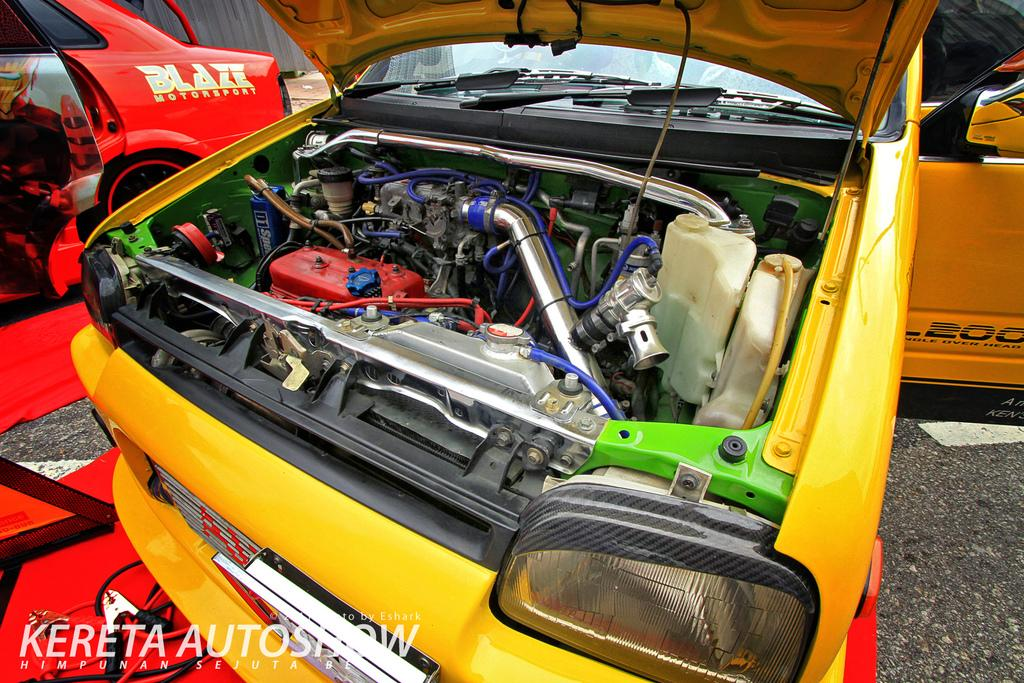What is the main subject in the middle of the picture? There is an engine of a vehicle in the middle of the picture. What type of vehicle might the engine belong to? The specific type of vehicle cannot be determined from the image. What can be seen on the right side of the picture? There is a red color car on the right side of the picture. Can you describe the color of the car? The car is red. Where is the playground located in the image? There is no playground present in the image. What type of ink is used to write the car's license plate number? The image does not show the car's license plate number, so it cannot be determined what type of ink is used. 